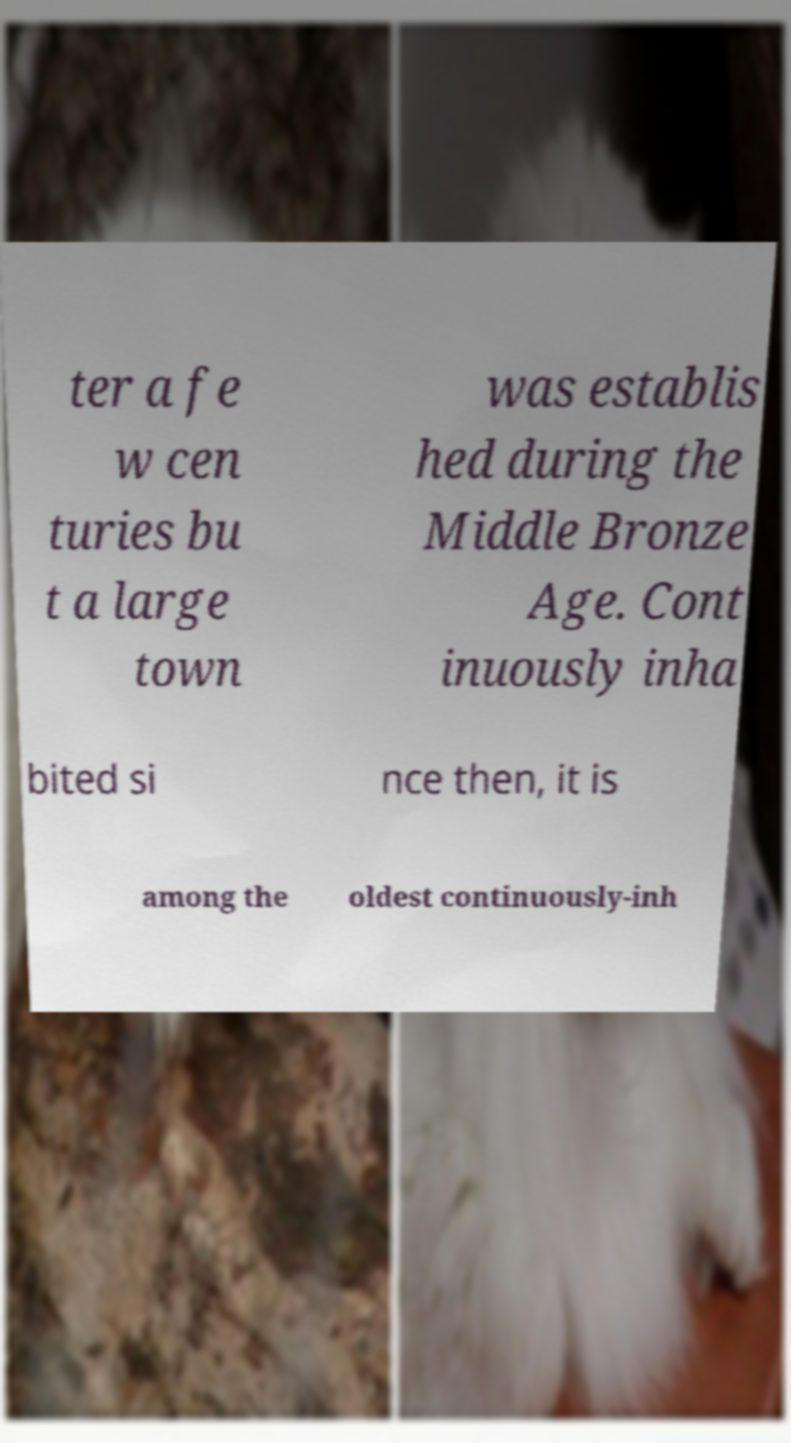There's text embedded in this image that I need extracted. Can you transcribe it verbatim? ter a fe w cen turies bu t a large town was establis hed during the Middle Bronze Age. Cont inuously inha bited si nce then, it is among the oldest continuously-inh 